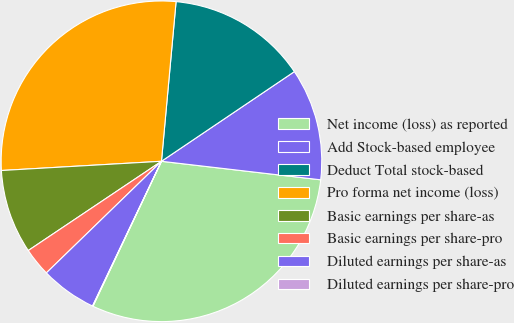<chart> <loc_0><loc_0><loc_500><loc_500><pie_chart><fcel>Net income (loss) as reported<fcel>Add Stock-based employee<fcel>Deduct Total stock-based<fcel>Pro forma net income (loss)<fcel>Basic earnings per share-as<fcel>Basic earnings per share-pro<fcel>Diluted earnings per share-as<fcel>Diluted earnings per share-pro<nl><fcel>30.18%<fcel>11.29%<fcel>14.1%<fcel>27.37%<fcel>8.48%<fcel>2.86%<fcel>5.67%<fcel>0.05%<nl></chart> 